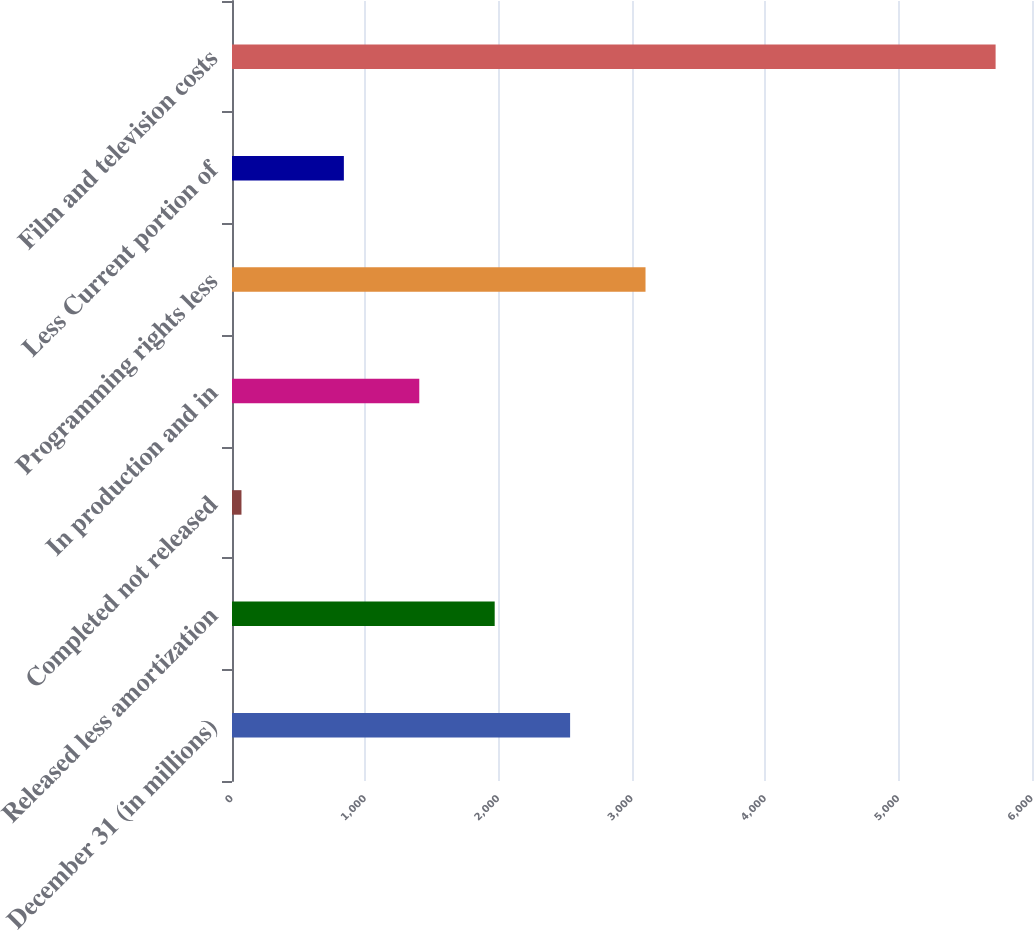<chart> <loc_0><loc_0><loc_500><loc_500><bar_chart><fcel>December 31 (in millions)<fcel>Released less amortization<fcel>Completed not released<fcel>In production and in<fcel>Programming rights less<fcel>Less Current portion of<fcel>Film and television costs<nl><fcel>2535.8<fcel>1970.2<fcel>71<fcel>1404.6<fcel>3101.4<fcel>839<fcel>5727<nl></chart> 